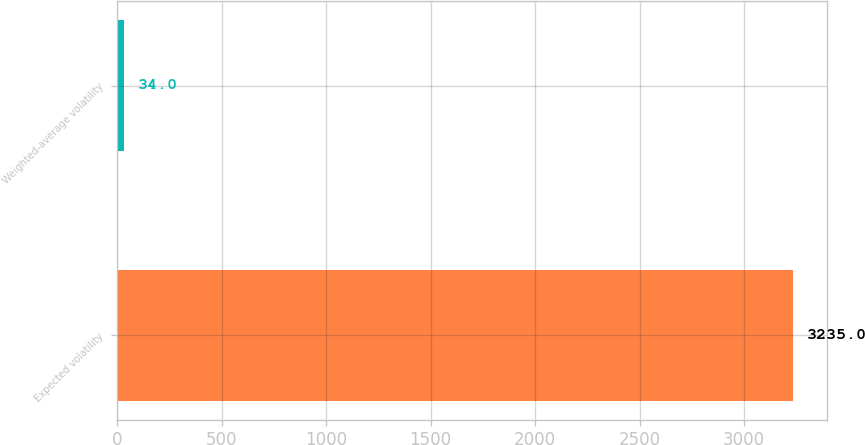<chart> <loc_0><loc_0><loc_500><loc_500><bar_chart><fcel>Expected volatility<fcel>Weighted-average volatility<nl><fcel>3235<fcel>34<nl></chart> 